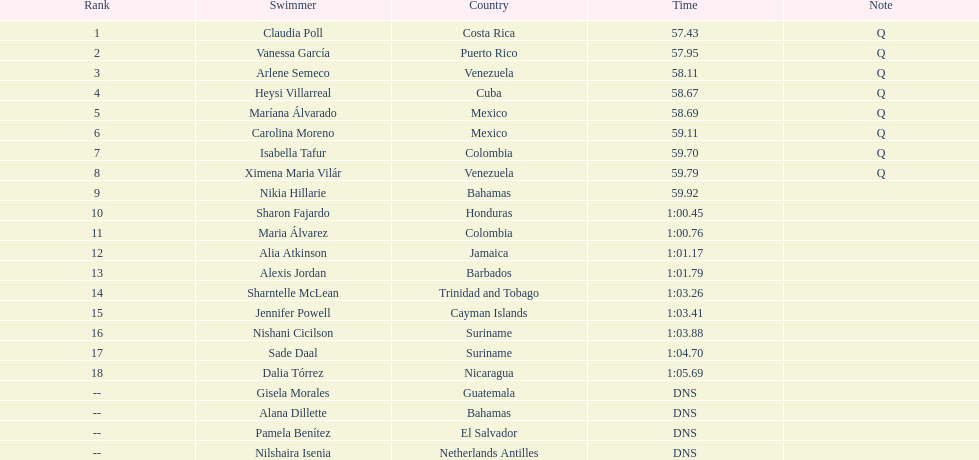What's the count of swimmers hailing from mexico? 2. 